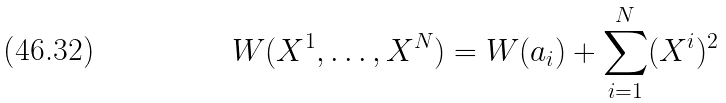<formula> <loc_0><loc_0><loc_500><loc_500>W ( X ^ { 1 } , \dots , X ^ { N } ) = W ( a _ { i } ) + \sum _ { i = 1 } ^ { N } ( X ^ { i } ) ^ { 2 }</formula> 